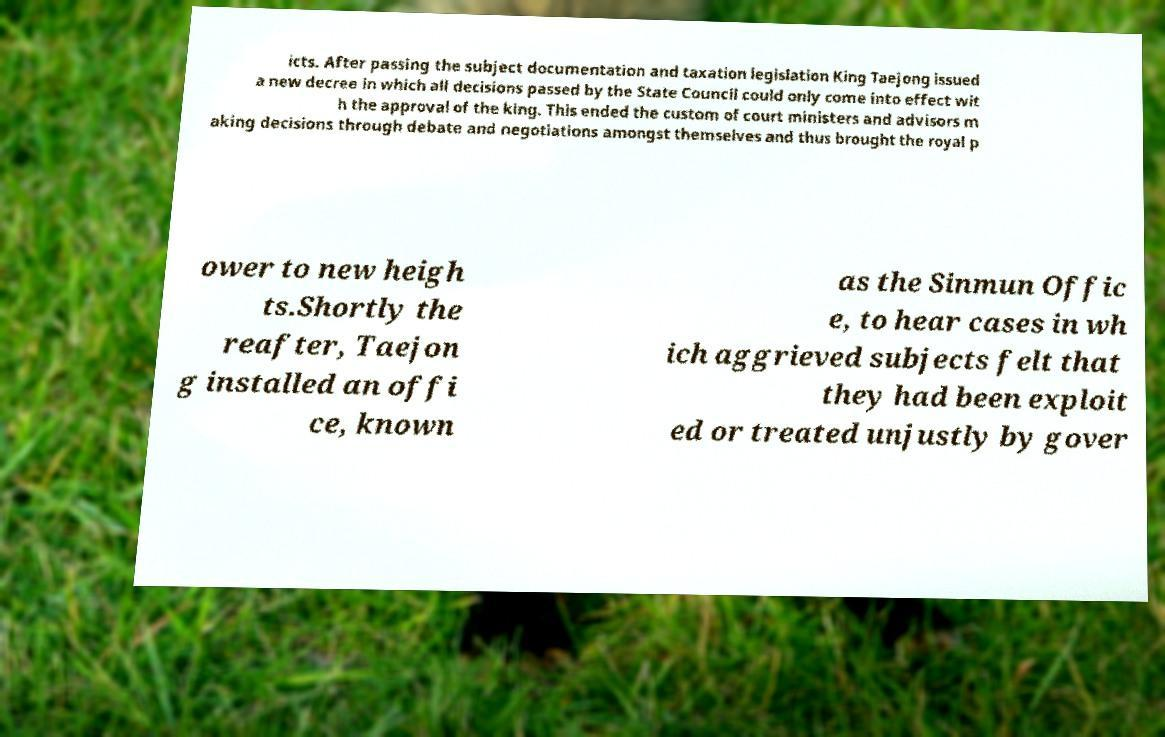What messages or text are displayed in this image? I need them in a readable, typed format. icts. After passing the subject documentation and taxation legislation King Taejong issued a new decree in which all decisions passed by the State Council could only come into effect wit h the approval of the king. This ended the custom of court ministers and advisors m aking decisions through debate and negotiations amongst themselves and thus brought the royal p ower to new heigh ts.Shortly the reafter, Taejon g installed an offi ce, known as the Sinmun Offic e, to hear cases in wh ich aggrieved subjects felt that they had been exploit ed or treated unjustly by gover 